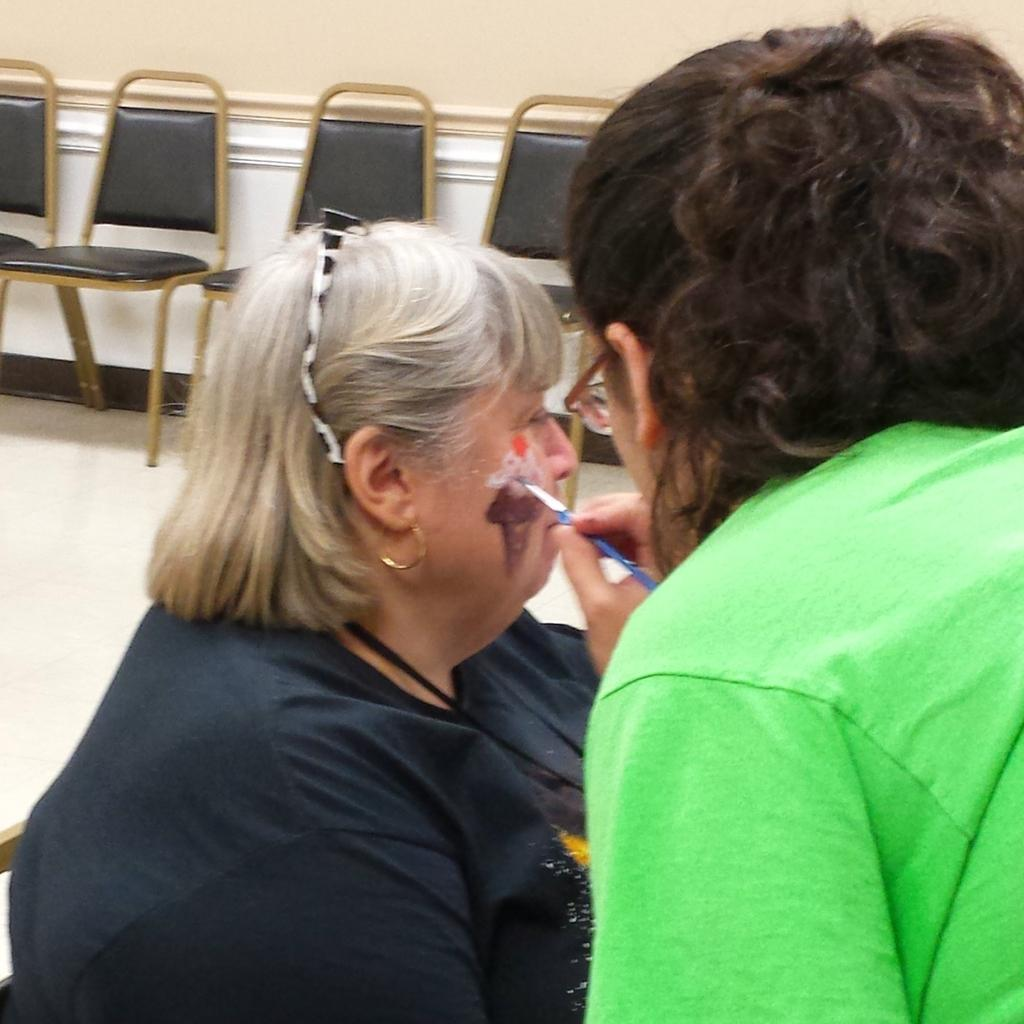What is the person in the image holding? The person is holding a brush in the image. What is the person with the brush doing to the other person? The person with the brush is likely painting or applying something to the other person, who is sitting in front of them. What can be seen in the background of the image? There is a wall and chairs in the background of the image. What type of spy equipment can be seen in the image? There is no spy equipment present in the image. What kind of teeth can be seen in the image? There are no teeth visible in the image, as it features a person holding a brush and a woman sitting in front of them. 